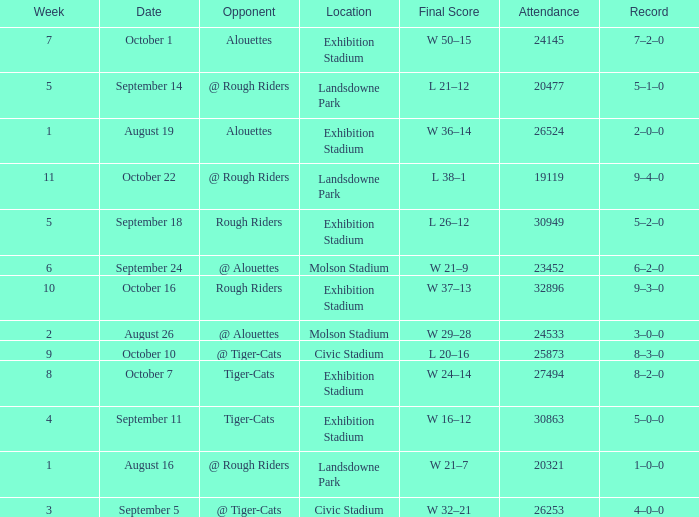What is the least value for week? 1.0. 